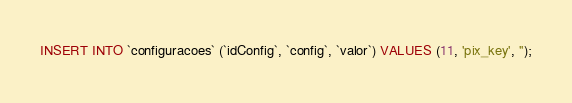<code> <loc_0><loc_0><loc_500><loc_500><_SQL_>INSERT INTO `configuracoes` (`idConfig`, `config`, `valor`) VALUES (11, 'pix_key', '');
</code> 